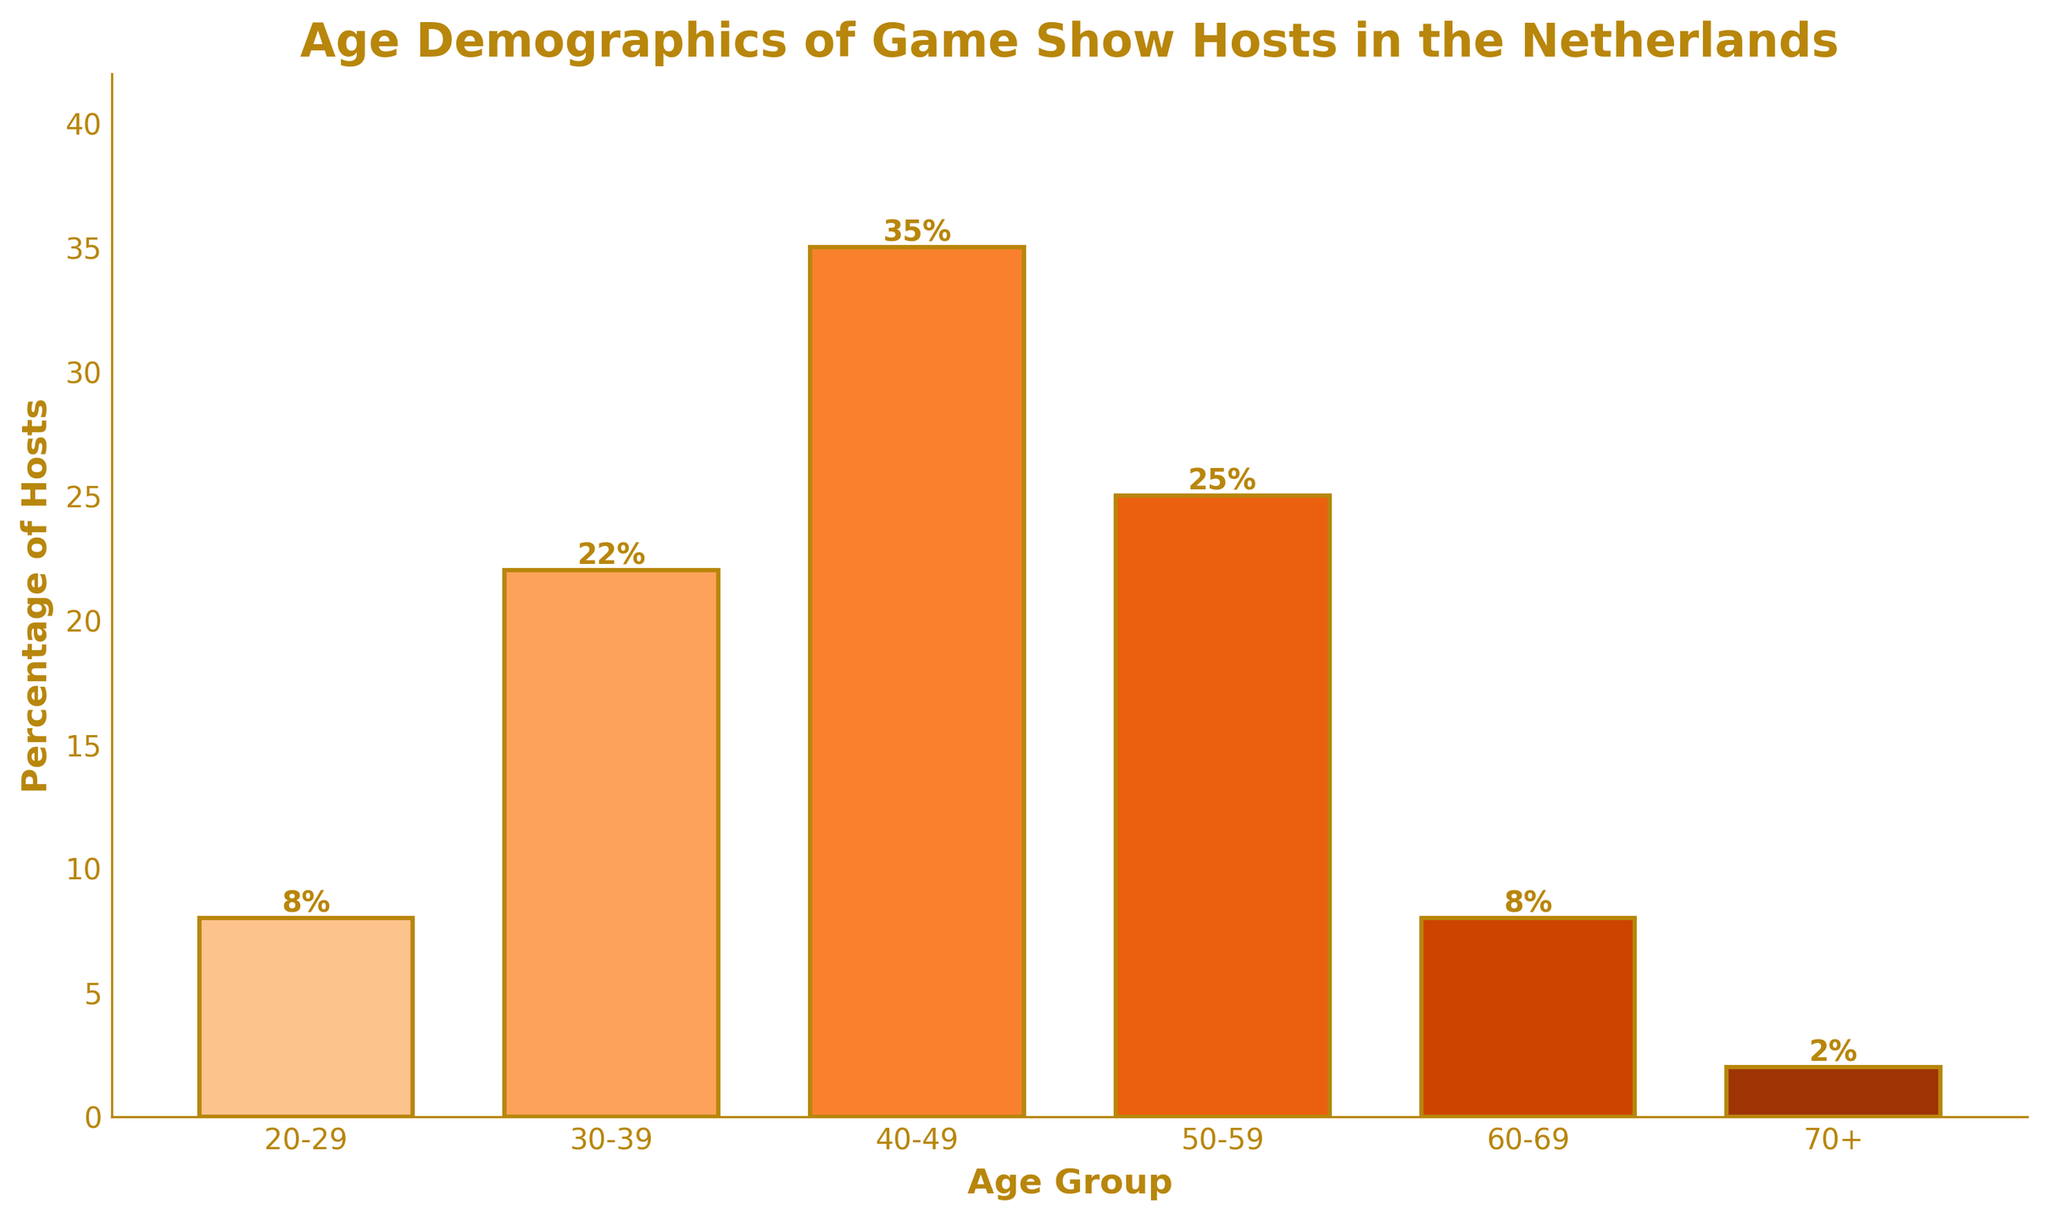What is the most common age group of game show hosts? The bar representing the age group 40-49 is the tallest among all the bars, indicating the highest percentage at 35%.
Answer: 40-49 Which two age groups have the same percentage of game show hosts? The bars for age groups 20-29 and 60-69 both have the same height, representing a percentage of 8%.
Answer: 20-29 and 60-69 What is the combined percentage of game show hosts who are aged 50 or older? To find this, add the percentages of the age groups 50-59, 60-69, and 70+: 25% + 8% + 2% = 35%.
Answer: 35% Which age group has twice the percentage of hosts compared to the age group 30-39? The age group 40-49 has 35%, which is approximately 1.6 times the percentage of the age group 30-39 (22%). Doubling the percentage of 30-39 would be realistic but approximate to find the group with highest percentage closely: 22% * 2 = 44%.
Answer: 40-49 How does the percentage of game show hosts aged 70+ compare to those aged 30-39? The bar for the age group 70+ is shorter and has a lower percentage (2%) compared to the age group 30-39 (22%).
Answer: 70+ is much lower than 30-39 What percentage of game show hosts are younger than 40? Add the percentages of the age groups 20-29 and 30-39: 8% + 22% = 30%.
Answer: 30% What percentage of game show hosts are within the age range of 40-59? Add the percentages of the age groups 40-49 and 50-59: 35% + 25% = 60%.
Answer: 60% What differences in percentages do you observe between the age groups 50-59 and 60-69? Subtract the percentage of the age group 60-69 from the percentage of the age group 50-59: 25% - 8% = 17%.
Answer: 17% Which age group represents 1/4 of the game show host population? To find 1/4 of the total percentage (100%), it corresponds to 25%. The age group 50-59 represents exactly 25%.
Answer: 50-59 